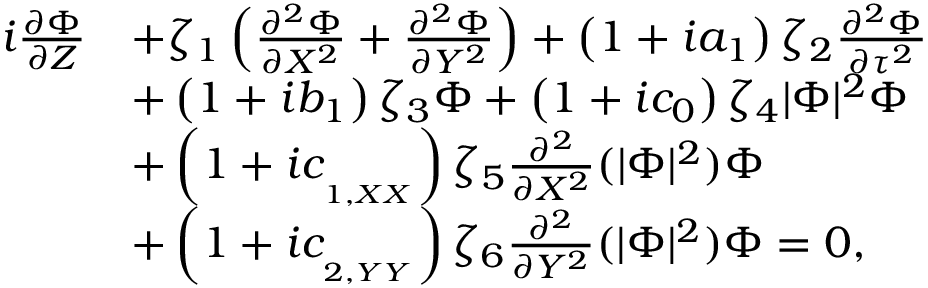Convert formula to latex. <formula><loc_0><loc_0><loc_500><loc_500>\begin{array} { r l } { i \frac { \partial \Phi } { \partial Z } } & { + \zeta _ { 1 } \left ( \frac { \partial ^ { 2 } \Phi } { \partial X ^ { 2 } } + \frac { \partial ^ { 2 } \Phi } { \partial Y ^ { 2 } } \right ) + \left ( 1 + i a _ { 1 } \right ) \zeta _ { 2 } \frac { \partial ^ { 2 } \Phi } { \partial \tau ^ { 2 } } } \\ & { + \left ( 1 + i b _ { 1 } \right ) \zeta _ { 3 } \Phi + \left ( 1 + i c _ { 0 } \right ) \zeta _ { 4 } | \Phi | ^ { 2 } \Phi } \\ & { + \left ( 1 + i c _ { _ { _ { 1 , X X } } } \right ) \zeta _ { 5 } \frac { \partial ^ { 2 } } { \partial X ^ { 2 } } ( | \Phi | ^ { 2 } ) \Phi } \\ & { + \left ( 1 + i c _ { _ { _ { 2 , Y Y } } } \right ) \zeta _ { 6 } \frac { \partial ^ { 2 } } { \partial Y ^ { 2 } } ( | \Phi | ^ { 2 } ) \Phi = 0 , } \end{array}</formula> 